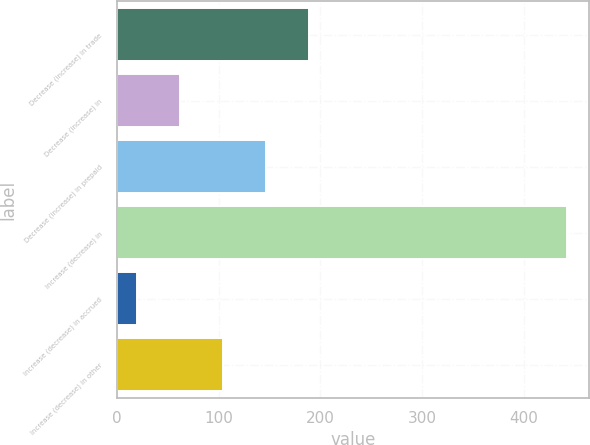Convert chart to OTSL. <chart><loc_0><loc_0><loc_500><loc_500><bar_chart><fcel>Decrease (increase) in trade<fcel>Decrease (increase) in<fcel>Decrease (increase) in prepaid<fcel>Increase (decrease) in<fcel>Increase (decrease) in accrued<fcel>Increase (decrease) in other<nl><fcel>188.8<fcel>62.2<fcel>146.6<fcel>442<fcel>20<fcel>104.4<nl></chart> 